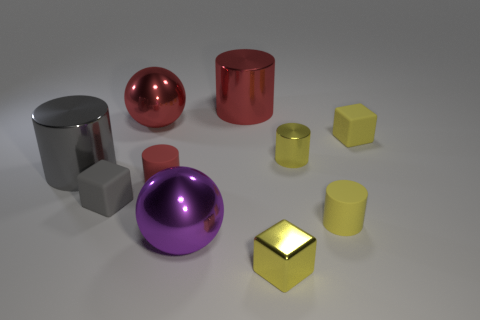Subtract all red rubber cylinders. How many cylinders are left? 4 Subtract all gray spheres. How many yellow cubes are left? 2 Subtract 2 cylinders. How many cylinders are left? 3 Subtract all gray cubes. How many cubes are left? 2 Subtract 1 red spheres. How many objects are left? 9 Subtract all balls. How many objects are left? 8 Subtract all green cylinders. Subtract all brown blocks. How many cylinders are left? 5 Subtract all red matte cylinders. Subtract all green shiny things. How many objects are left? 9 Add 4 metallic cylinders. How many metallic cylinders are left? 7 Add 6 big metallic spheres. How many big metallic spheres exist? 8 